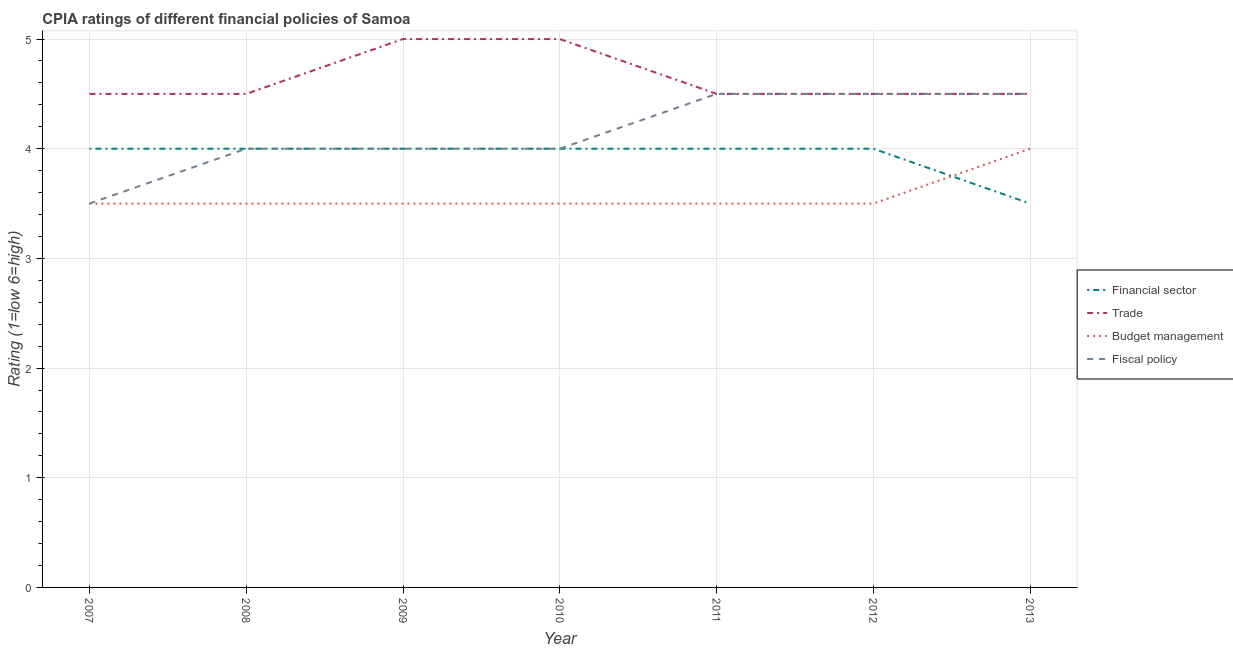How many different coloured lines are there?
Provide a short and direct response. 4. Does the line corresponding to cpia rating of trade intersect with the line corresponding to cpia rating of budget management?
Make the answer very short. No. Is the number of lines equal to the number of legend labels?
Your answer should be very brief. Yes. Across all years, what is the maximum cpia rating of budget management?
Provide a succinct answer. 4. In which year was the cpia rating of fiscal policy maximum?
Your response must be concise. 2011. What is the difference between the cpia rating of fiscal policy in 2009 and that in 2012?
Keep it short and to the point. -0.5. What is the difference between the cpia rating of financial sector in 2012 and the cpia rating of budget management in 2007?
Offer a very short reply. 0.5. What is the average cpia rating of trade per year?
Your answer should be very brief. 4.64. In the year 2011, what is the difference between the cpia rating of budget management and cpia rating of fiscal policy?
Ensure brevity in your answer.  -1. What is the ratio of the cpia rating of budget management in 2010 to that in 2011?
Offer a terse response. 1. Is the cpia rating of trade in 2010 less than that in 2013?
Ensure brevity in your answer.  No. Is the difference between the cpia rating of trade in 2008 and 2013 greater than the difference between the cpia rating of budget management in 2008 and 2013?
Your response must be concise. Yes. What is the difference between the highest and the lowest cpia rating of trade?
Offer a terse response. 0.5. In how many years, is the cpia rating of budget management greater than the average cpia rating of budget management taken over all years?
Your answer should be very brief. 1. Is the sum of the cpia rating of fiscal policy in 2008 and 2011 greater than the maximum cpia rating of trade across all years?
Offer a very short reply. Yes. Is it the case that in every year, the sum of the cpia rating of financial sector and cpia rating of trade is greater than the cpia rating of budget management?
Offer a very short reply. Yes. How many lines are there?
Keep it short and to the point. 4. Are the values on the major ticks of Y-axis written in scientific E-notation?
Your answer should be very brief. No. Does the graph contain any zero values?
Your response must be concise. No. Does the graph contain grids?
Offer a terse response. Yes. How many legend labels are there?
Keep it short and to the point. 4. How are the legend labels stacked?
Make the answer very short. Vertical. What is the title of the graph?
Your answer should be very brief. CPIA ratings of different financial policies of Samoa. Does "Payroll services" appear as one of the legend labels in the graph?
Offer a terse response. No. What is the label or title of the X-axis?
Provide a short and direct response. Year. What is the label or title of the Y-axis?
Ensure brevity in your answer.  Rating (1=low 6=high). What is the Rating (1=low 6=high) of Financial sector in 2007?
Keep it short and to the point. 4. What is the Rating (1=low 6=high) of Trade in 2007?
Your response must be concise. 4.5. What is the Rating (1=low 6=high) in Financial sector in 2008?
Offer a very short reply. 4. What is the Rating (1=low 6=high) in Trade in 2008?
Provide a short and direct response. 4.5. What is the Rating (1=low 6=high) of Budget management in 2008?
Your answer should be compact. 3.5. What is the Rating (1=low 6=high) in Fiscal policy in 2008?
Your response must be concise. 4. What is the Rating (1=low 6=high) in Trade in 2009?
Your answer should be very brief. 5. What is the Rating (1=low 6=high) in Trade in 2010?
Ensure brevity in your answer.  5. What is the Rating (1=low 6=high) of Fiscal policy in 2010?
Provide a succinct answer. 4. What is the Rating (1=low 6=high) in Financial sector in 2012?
Provide a short and direct response. 4. What is the Rating (1=low 6=high) in Fiscal policy in 2012?
Give a very brief answer. 4.5. What is the Rating (1=low 6=high) in Trade in 2013?
Offer a terse response. 4.5. What is the Rating (1=low 6=high) of Budget management in 2013?
Provide a succinct answer. 4. What is the Rating (1=low 6=high) in Fiscal policy in 2013?
Offer a terse response. 4.5. Across all years, what is the maximum Rating (1=low 6=high) in Financial sector?
Provide a short and direct response. 4. Across all years, what is the maximum Rating (1=low 6=high) in Trade?
Your answer should be very brief. 5. Across all years, what is the maximum Rating (1=low 6=high) in Budget management?
Offer a very short reply. 4. Across all years, what is the minimum Rating (1=low 6=high) of Financial sector?
Offer a very short reply. 3.5. Across all years, what is the minimum Rating (1=low 6=high) of Budget management?
Provide a short and direct response. 3.5. What is the total Rating (1=low 6=high) in Financial sector in the graph?
Make the answer very short. 27.5. What is the total Rating (1=low 6=high) in Trade in the graph?
Offer a very short reply. 32.5. What is the total Rating (1=low 6=high) of Budget management in the graph?
Provide a short and direct response. 25. What is the total Rating (1=low 6=high) of Fiscal policy in the graph?
Your response must be concise. 29. What is the difference between the Rating (1=low 6=high) in Trade in 2007 and that in 2008?
Make the answer very short. 0. What is the difference between the Rating (1=low 6=high) in Budget management in 2007 and that in 2008?
Offer a terse response. 0. What is the difference between the Rating (1=low 6=high) of Trade in 2007 and that in 2009?
Give a very brief answer. -0.5. What is the difference between the Rating (1=low 6=high) of Budget management in 2007 and that in 2009?
Your response must be concise. 0. What is the difference between the Rating (1=low 6=high) of Financial sector in 2007 and that in 2010?
Your answer should be very brief. 0. What is the difference between the Rating (1=low 6=high) of Trade in 2007 and that in 2010?
Offer a very short reply. -0.5. What is the difference between the Rating (1=low 6=high) of Budget management in 2007 and that in 2010?
Give a very brief answer. 0. What is the difference between the Rating (1=low 6=high) in Financial sector in 2007 and that in 2011?
Your response must be concise. 0. What is the difference between the Rating (1=low 6=high) of Trade in 2007 and that in 2011?
Your answer should be very brief. 0. What is the difference between the Rating (1=low 6=high) of Financial sector in 2007 and that in 2013?
Your answer should be very brief. 0.5. What is the difference between the Rating (1=low 6=high) of Budget management in 2007 and that in 2013?
Offer a terse response. -0.5. What is the difference between the Rating (1=low 6=high) of Fiscal policy in 2007 and that in 2013?
Your answer should be very brief. -1. What is the difference between the Rating (1=low 6=high) in Financial sector in 2008 and that in 2009?
Keep it short and to the point. 0. What is the difference between the Rating (1=low 6=high) of Trade in 2008 and that in 2009?
Provide a succinct answer. -0.5. What is the difference between the Rating (1=low 6=high) of Budget management in 2008 and that in 2009?
Give a very brief answer. 0. What is the difference between the Rating (1=low 6=high) of Trade in 2008 and that in 2010?
Offer a very short reply. -0.5. What is the difference between the Rating (1=low 6=high) of Financial sector in 2008 and that in 2011?
Make the answer very short. 0. What is the difference between the Rating (1=low 6=high) of Trade in 2008 and that in 2011?
Offer a terse response. 0. What is the difference between the Rating (1=low 6=high) of Budget management in 2008 and that in 2011?
Provide a succinct answer. 0. What is the difference between the Rating (1=low 6=high) of Financial sector in 2008 and that in 2012?
Offer a terse response. 0. What is the difference between the Rating (1=low 6=high) in Trade in 2008 and that in 2012?
Provide a succinct answer. 0. What is the difference between the Rating (1=low 6=high) in Budget management in 2008 and that in 2012?
Provide a succinct answer. 0. What is the difference between the Rating (1=low 6=high) of Fiscal policy in 2008 and that in 2012?
Offer a very short reply. -0.5. What is the difference between the Rating (1=low 6=high) in Trade in 2008 and that in 2013?
Offer a terse response. 0. What is the difference between the Rating (1=low 6=high) of Budget management in 2008 and that in 2013?
Give a very brief answer. -0.5. What is the difference between the Rating (1=low 6=high) of Fiscal policy in 2008 and that in 2013?
Provide a short and direct response. -0.5. What is the difference between the Rating (1=low 6=high) of Financial sector in 2009 and that in 2011?
Provide a succinct answer. 0. What is the difference between the Rating (1=low 6=high) in Trade in 2009 and that in 2011?
Your answer should be compact. 0.5. What is the difference between the Rating (1=low 6=high) in Fiscal policy in 2009 and that in 2011?
Make the answer very short. -0.5. What is the difference between the Rating (1=low 6=high) in Financial sector in 2009 and that in 2012?
Keep it short and to the point. 0. What is the difference between the Rating (1=low 6=high) in Trade in 2009 and that in 2012?
Offer a terse response. 0.5. What is the difference between the Rating (1=low 6=high) of Budget management in 2009 and that in 2012?
Ensure brevity in your answer.  0. What is the difference between the Rating (1=low 6=high) in Fiscal policy in 2009 and that in 2012?
Provide a succinct answer. -0.5. What is the difference between the Rating (1=low 6=high) of Trade in 2009 and that in 2013?
Ensure brevity in your answer.  0.5. What is the difference between the Rating (1=low 6=high) of Budget management in 2009 and that in 2013?
Provide a succinct answer. -0.5. What is the difference between the Rating (1=low 6=high) in Trade in 2010 and that in 2011?
Your answer should be compact. 0.5. What is the difference between the Rating (1=low 6=high) in Budget management in 2010 and that in 2011?
Provide a succinct answer. 0. What is the difference between the Rating (1=low 6=high) in Fiscal policy in 2010 and that in 2012?
Keep it short and to the point. -0.5. What is the difference between the Rating (1=low 6=high) of Trade in 2010 and that in 2013?
Keep it short and to the point. 0.5. What is the difference between the Rating (1=low 6=high) in Budget management in 2010 and that in 2013?
Keep it short and to the point. -0.5. What is the difference between the Rating (1=low 6=high) in Fiscal policy in 2010 and that in 2013?
Provide a short and direct response. -0.5. What is the difference between the Rating (1=low 6=high) of Trade in 2011 and that in 2012?
Give a very brief answer. 0. What is the difference between the Rating (1=low 6=high) in Budget management in 2011 and that in 2012?
Offer a terse response. 0. What is the difference between the Rating (1=low 6=high) of Financial sector in 2011 and that in 2013?
Give a very brief answer. 0.5. What is the difference between the Rating (1=low 6=high) in Financial sector in 2012 and that in 2013?
Your answer should be very brief. 0.5. What is the difference between the Rating (1=low 6=high) of Trade in 2012 and that in 2013?
Provide a succinct answer. 0. What is the difference between the Rating (1=low 6=high) in Budget management in 2012 and that in 2013?
Your response must be concise. -0.5. What is the difference between the Rating (1=low 6=high) of Fiscal policy in 2012 and that in 2013?
Ensure brevity in your answer.  0. What is the difference between the Rating (1=low 6=high) of Financial sector in 2007 and the Rating (1=low 6=high) of Trade in 2008?
Keep it short and to the point. -0.5. What is the difference between the Rating (1=low 6=high) in Financial sector in 2007 and the Rating (1=low 6=high) in Budget management in 2008?
Your answer should be compact. 0.5. What is the difference between the Rating (1=low 6=high) of Financial sector in 2007 and the Rating (1=low 6=high) of Fiscal policy in 2008?
Your answer should be very brief. 0. What is the difference between the Rating (1=low 6=high) of Trade in 2007 and the Rating (1=low 6=high) of Budget management in 2008?
Your answer should be very brief. 1. What is the difference between the Rating (1=low 6=high) in Financial sector in 2007 and the Rating (1=low 6=high) in Budget management in 2009?
Offer a terse response. 0.5. What is the difference between the Rating (1=low 6=high) of Trade in 2007 and the Rating (1=low 6=high) of Budget management in 2009?
Provide a succinct answer. 1. What is the difference between the Rating (1=low 6=high) in Budget management in 2007 and the Rating (1=low 6=high) in Fiscal policy in 2009?
Your answer should be very brief. -0.5. What is the difference between the Rating (1=low 6=high) of Budget management in 2007 and the Rating (1=low 6=high) of Fiscal policy in 2010?
Offer a very short reply. -0.5. What is the difference between the Rating (1=low 6=high) of Trade in 2007 and the Rating (1=low 6=high) of Budget management in 2011?
Your response must be concise. 1. What is the difference between the Rating (1=low 6=high) of Budget management in 2007 and the Rating (1=low 6=high) of Fiscal policy in 2011?
Give a very brief answer. -1. What is the difference between the Rating (1=low 6=high) of Financial sector in 2007 and the Rating (1=low 6=high) of Trade in 2012?
Your response must be concise. -0.5. What is the difference between the Rating (1=low 6=high) in Financial sector in 2007 and the Rating (1=low 6=high) in Budget management in 2012?
Provide a short and direct response. 0.5. What is the difference between the Rating (1=low 6=high) in Financial sector in 2007 and the Rating (1=low 6=high) in Fiscal policy in 2012?
Offer a very short reply. -0.5. What is the difference between the Rating (1=low 6=high) of Trade in 2007 and the Rating (1=low 6=high) of Budget management in 2012?
Ensure brevity in your answer.  1. What is the difference between the Rating (1=low 6=high) in Trade in 2007 and the Rating (1=low 6=high) in Fiscal policy in 2012?
Your answer should be very brief. 0. What is the difference between the Rating (1=low 6=high) of Budget management in 2007 and the Rating (1=low 6=high) of Fiscal policy in 2012?
Your answer should be compact. -1. What is the difference between the Rating (1=low 6=high) in Financial sector in 2007 and the Rating (1=low 6=high) in Fiscal policy in 2013?
Give a very brief answer. -0.5. What is the difference between the Rating (1=low 6=high) of Trade in 2007 and the Rating (1=low 6=high) of Budget management in 2013?
Provide a short and direct response. 0.5. What is the difference between the Rating (1=low 6=high) in Budget management in 2007 and the Rating (1=low 6=high) in Fiscal policy in 2013?
Offer a terse response. -1. What is the difference between the Rating (1=low 6=high) in Financial sector in 2008 and the Rating (1=low 6=high) in Budget management in 2009?
Provide a succinct answer. 0.5. What is the difference between the Rating (1=low 6=high) of Budget management in 2008 and the Rating (1=low 6=high) of Fiscal policy in 2009?
Your answer should be compact. -0.5. What is the difference between the Rating (1=low 6=high) in Financial sector in 2008 and the Rating (1=low 6=high) in Trade in 2010?
Offer a very short reply. -1. What is the difference between the Rating (1=low 6=high) in Financial sector in 2008 and the Rating (1=low 6=high) in Fiscal policy in 2010?
Make the answer very short. 0. What is the difference between the Rating (1=low 6=high) of Budget management in 2008 and the Rating (1=low 6=high) of Fiscal policy in 2010?
Your answer should be very brief. -0.5. What is the difference between the Rating (1=low 6=high) of Financial sector in 2008 and the Rating (1=low 6=high) of Trade in 2011?
Your answer should be compact. -0.5. What is the difference between the Rating (1=low 6=high) in Trade in 2008 and the Rating (1=low 6=high) in Budget management in 2011?
Your answer should be very brief. 1. What is the difference between the Rating (1=low 6=high) of Budget management in 2008 and the Rating (1=low 6=high) of Fiscal policy in 2011?
Give a very brief answer. -1. What is the difference between the Rating (1=low 6=high) in Financial sector in 2008 and the Rating (1=low 6=high) in Fiscal policy in 2012?
Your response must be concise. -0.5. What is the difference between the Rating (1=low 6=high) in Trade in 2008 and the Rating (1=low 6=high) in Fiscal policy in 2012?
Ensure brevity in your answer.  0. What is the difference between the Rating (1=low 6=high) of Budget management in 2008 and the Rating (1=low 6=high) of Fiscal policy in 2012?
Keep it short and to the point. -1. What is the difference between the Rating (1=low 6=high) of Financial sector in 2008 and the Rating (1=low 6=high) of Budget management in 2013?
Ensure brevity in your answer.  0. What is the difference between the Rating (1=low 6=high) in Financial sector in 2009 and the Rating (1=low 6=high) in Budget management in 2010?
Your response must be concise. 0.5. What is the difference between the Rating (1=low 6=high) in Financial sector in 2009 and the Rating (1=low 6=high) in Trade in 2011?
Offer a very short reply. -0.5. What is the difference between the Rating (1=low 6=high) in Financial sector in 2009 and the Rating (1=low 6=high) in Fiscal policy in 2012?
Ensure brevity in your answer.  -0.5. What is the difference between the Rating (1=low 6=high) in Trade in 2009 and the Rating (1=low 6=high) in Budget management in 2012?
Offer a very short reply. 1.5. What is the difference between the Rating (1=low 6=high) of Financial sector in 2009 and the Rating (1=low 6=high) of Trade in 2013?
Provide a succinct answer. -0.5. What is the difference between the Rating (1=low 6=high) of Financial sector in 2009 and the Rating (1=low 6=high) of Fiscal policy in 2013?
Provide a short and direct response. -0.5. What is the difference between the Rating (1=low 6=high) of Trade in 2009 and the Rating (1=low 6=high) of Budget management in 2013?
Your answer should be compact. 1. What is the difference between the Rating (1=low 6=high) of Budget management in 2009 and the Rating (1=low 6=high) of Fiscal policy in 2013?
Offer a terse response. -1. What is the difference between the Rating (1=low 6=high) of Financial sector in 2010 and the Rating (1=low 6=high) of Trade in 2011?
Make the answer very short. -0.5. What is the difference between the Rating (1=low 6=high) in Financial sector in 2010 and the Rating (1=low 6=high) in Budget management in 2011?
Give a very brief answer. 0.5. What is the difference between the Rating (1=low 6=high) of Financial sector in 2010 and the Rating (1=low 6=high) of Fiscal policy in 2011?
Offer a terse response. -0.5. What is the difference between the Rating (1=low 6=high) in Trade in 2010 and the Rating (1=low 6=high) in Budget management in 2011?
Keep it short and to the point. 1.5. What is the difference between the Rating (1=low 6=high) in Trade in 2010 and the Rating (1=low 6=high) in Fiscal policy in 2011?
Your answer should be compact. 0.5. What is the difference between the Rating (1=low 6=high) in Financial sector in 2010 and the Rating (1=low 6=high) in Trade in 2012?
Your response must be concise. -0.5. What is the difference between the Rating (1=low 6=high) in Financial sector in 2010 and the Rating (1=low 6=high) in Budget management in 2012?
Provide a succinct answer. 0.5. What is the difference between the Rating (1=low 6=high) of Financial sector in 2010 and the Rating (1=low 6=high) of Fiscal policy in 2012?
Your answer should be compact. -0.5. What is the difference between the Rating (1=low 6=high) of Budget management in 2010 and the Rating (1=low 6=high) of Fiscal policy in 2012?
Give a very brief answer. -1. What is the difference between the Rating (1=low 6=high) in Financial sector in 2010 and the Rating (1=low 6=high) in Trade in 2013?
Offer a very short reply. -0.5. What is the difference between the Rating (1=low 6=high) in Trade in 2010 and the Rating (1=low 6=high) in Budget management in 2013?
Keep it short and to the point. 1. What is the difference between the Rating (1=low 6=high) in Budget management in 2010 and the Rating (1=low 6=high) in Fiscal policy in 2013?
Provide a succinct answer. -1. What is the difference between the Rating (1=low 6=high) of Financial sector in 2011 and the Rating (1=low 6=high) of Budget management in 2012?
Offer a very short reply. 0.5. What is the difference between the Rating (1=low 6=high) in Trade in 2011 and the Rating (1=low 6=high) in Budget management in 2012?
Your response must be concise. 1. What is the difference between the Rating (1=low 6=high) of Trade in 2011 and the Rating (1=low 6=high) of Fiscal policy in 2012?
Your response must be concise. 0. What is the difference between the Rating (1=low 6=high) of Financial sector in 2011 and the Rating (1=low 6=high) of Budget management in 2013?
Provide a succinct answer. 0. What is the difference between the Rating (1=low 6=high) of Trade in 2011 and the Rating (1=low 6=high) of Fiscal policy in 2013?
Your answer should be compact. 0. What is the difference between the Rating (1=low 6=high) in Budget management in 2011 and the Rating (1=low 6=high) in Fiscal policy in 2013?
Your answer should be very brief. -1. What is the difference between the Rating (1=low 6=high) of Financial sector in 2012 and the Rating (1=low 6=high) of Trade in 2013?
Offer a very short reply. -0.5. What is the difference between the Rating (1=low 6=high) of Financial sector in 2012 and the Rating (1=low 6=high) of Budget management in 2013?
Keep it short and to the point. 0. What is the difference between the Rating (1=low 6=high) of Financial sector in 2012 and the Rating (1=low 6=high) of Fiscal policy in 2013?
Offer a very short reply. -0.5. What is the difference between the Rating (1=low 6=high) of Trade in 2012 and the Rating (1=low 6=high) of Fiscal policy in 2013?
Make the answer very short. 0. What is the average Rating (1=low 6=high) in Financial sector per year?
Offer a very short reply. 3.93. What is the average Rating (1=low 6=high) in Trade per year?
Your response must be concise. 4.64. What is the average Rating (1=low 6=high) of Budget management per year?
Provide a succinct answer. 3.57. What is the average Rating (1=low 6=high) of Fiscal policy per year?
Make the answer very short. 4.14. In the year 2007, what is the difference between the Rating (1=low 6=high) in Financial sector and Rating (1=low 6=high) in Budget management?
Provide a succinct answer. 0.5. In the year 2007, what is the difference between the Rating (1=low 6=high) of Budget management and Rating (1=low 6=high) of Fiscal policy?
Your answer should be very brief. 0. In the year 2008, what is the difference between the Rating (1=low 6=high) of Financial sector and Rating (1=low 6=high) of Trade?
Offer a very short reply. -0.5. In the year 2008, what is the difference between the Rating (1=low 6=high) of Financial sector and Rating (1=low 6=high) of Budget management?
Your response must be concise. 0.5. In the year 2008, what is the difference between the Rating (1=low 6=high) in Financial sector and Rating (1=low 6=high) in Fiscal policy?
Offer a terse response. 0. In the year 2008, what is the difference between the Rating (1=low 6=high) of Budget management and Rating (1=low 6=high) of Fiscal policy?
Provide a succinct answer. -0.5. In the year 2009, what is the difference between the Rating (1=low 6=high) in Trade and Rating (1=low 6=high) in Fiscal policy?
Offer a very short reply. 1. In the year 2010, what is the difference between the Rating (1=low 6=high) of Financial sector and Rating (1=low 6=high) of Trade?
Give a very brief answer. -1. In the year 2010, what is the difference between the Rating (1=low 6=high) in Financial sector and Rating (1=low 6=high) in Budget management?
Your response must be concise. 0.5. In the year 2010, what is the difference between the Rating (1=low 6=high) of Financial sector and Rating (1=low 6=high) of Fiscal policy?
Your answer should be compact. 0. In the year 2010, what is the difference between the Rating (1=low 6=high) of Trade and Rating (1=low 6=high) of Budget management?
Make the answer very short. 1.5. In the year 2010, what is the difference between the Rating (1=low 6=high) in Trade and Rating (1=low 6=high) in Fiscal policy?
Keep it short and to the point. 1. In the year 2010, what is the difference between the Rating (1=low 6=high) of Budget management and Rating (1=low 6=high) of Fiscal policy?
Provide a succinct answer. -0.5. In the year 2011, what is the difference between the Rating (1=low 6=high) in Financial sector and Rating (1=low 6=high) in Budget management?
Your response must be concise. 0.5. In the year 2011, what is the difference between the Rating (1=low 6=high) in Budget management and Rating (1=low 6=high) in Fiscal policy?
Give a very brief answer. -1. In the year 2012, what is the difference between the Rating (1=low 6=high) in Trade and Rating (1=low 6=high) in Budget management?
Your answer should be very brief. 1. In the year 2012, what is the difference between the Rating (1=low 6=high) in Trade and Rating (1=low 6=high) in Fiscal policy?
Your answer should be very brief. 0. In the year 2013, what is the difference between the Rating (1=low 6=high) of Financial sector and Rating (1=low 6=high) of Budget management?
Provide a succinct answer. -0.5. In the year 2013, what is the difference between the Rating (1=low 6=high) in Trade and Rating (1=low 6=high) in Budget management?
Keep it short and to the point. 0.5. In the year 2013, what is the difference between the Rating (1=low 6=high) in Trade and Rating (1=low 6=high) in Fiscal policy?
Offer a very short reply. 0. In the year 2013, what is the difference between the Rating (1=low 6=high) in Budget management and Rating (1=low 6=high) in Fiscal policy?
Offer a very short reply. -0.5. What is the ratio of the Rating (1=low 6=high) of Budget management in 2007 to that in 2008?
Your answer should be very brief. 1. What is the ratio of the Rating (1=low 6=high) in Financial sector in 2007 to that in 2009?
Provide a succinct answer. 1. What is the ratio of the Rating (1=low 6=high) of Budget management in 2007 to that in 2009?
Your answer should be very brief. 1. What is the ratio of the Rating (1=low 6=high) in Fiscal policy in 2007 to that in 2009?
Offer a very short reply. 0.88. What is the ratio of the Rating (1=low 6=high) of Trade in 2007 to that in 2010?
Give a very brief answer. 0.9. What is the ratio of the Rating (1=low 6=high) of Budget management in 2007 to that in 2010?
Your answer should be very brief. 1. What is the ratio of the Rating (1=low 6=high) of Trade in 2007 to that in 2011?
Ensure brevity in your answer.  1. What is the ratio of the Rating (1=low 6=high) of Budget management in 2007 to that in 2011?
Give a very brief answer. 1. What is the ratio of the Rating (1=low 6=high) of Financial sector in 2007 to that in 2012?
Your answer should be very brief. 1. What is the ratio of the Rating (1=low 6=high) of Fiscal policy in 2007 to that in 2012?
Provide a short and direct response. 0.78. What is the ratio of the Rating (1=low 6=high) in Budget management in 2007 to that in 2013?
Keep it short and to the point. 0.88. What is the ratio of the Rating (1=low 6=high) of Financial sector in 2008 to that in 2009?
Your response must be concise. 1. What is the ratio of the Rating (1=low 6=high) in Budget management in 2008 to that in 2009?
Give a very brief answer. 1. What is the ratio of the Rating (1=low 6=high) of Financial sector in 2008 to that in 2011?
Offer a terse response. 1. What is the ratio of the Rating (1=low 6=high) in Trade in 2008 to that in 2011?
Give a very brief answer. 1. What is the ratio of the Rating (1=low 6=high) in Budget management in 2008 to that in 2011?
Your answer should be compact. 1. What is the ratio of the Rating (1=low 6=high) of Trade in 2008 to that in 2012?
Your answer should be very brief. 1. What is the ratio of the Rating (1=low 6=high) in Financial sector in 2008 to that in 2013?
Provide a short and direct response. 1.14. What is the ratio of the Rating (1=low 6=high) in Budget management in 2008 to that in 2013?
Provide a short and direct response. 0.88. What is the ratio of the Rating (1=low 6=high) in Fiscal policy in 2008 to that in 2013?
Provide a succinct answer. 0.89. What is the ratio of the Rating (1=low 6=high) in Budget management in 2009 to that in 2010?
Your response must be concise. 1. What is the ratio of the Rating (1=low 6=high) of Financial sector in 2009 to that in 2011?
Ensure brevity in your answer.  1. What is the ratio of the Rating (1=low 6=high) in Trade in 2009 to that in 2011?
Your response must be concise. 1.11. What is the ratio of the Rating (1=low 6=high) of Budget management in 2009 to that in 2011?
Give a very brief answer. 1. What is the ratio of the Rating (1=low 6=high) in Financial sector in 2009 to that in 2012?
Your answer should be compact. 1. What is the ratio of the Rating (1=low 6=high) in Trade in 2009 to that in 2012?
Your response must be concise. 1.11. What is the ratio of the Rating (1=low 6=high) of Fiscal policy in 2009 to that in 2012?
Your answer should be compact. 0.89. What is the ratio of the Rating (1=low 6=high) in Financial sector in 2009 to that in 2013?
Make the answer very short. 1.14. What is the ratio of the Rating (1=low 6=high) of Budget management in 2009 to that in 2013?
Your answer should be very brief. 0.88. What is the ratio of the Rating (1=low 6=high) in Fiscal policy in 2009 to that in 2013?
Give a very brief answer. 0.89. What is the ratio of the Rating (1=low 6=high) in Financial sector in 2010 to that in 2011?
Ensure brevity in your answer.  1. What is the ratio of the Rating (1=low 6=high) of Fiscal policy in 2010 to that in 2011?
Give a very brief answer. 0.89. What is the ratio of the Rating (1=low 6=high) in Financial sector in 2010 to that in 2012?
Give a very brief answer. 1. What is the ratio of the Rating (1=low 6=high) in Trade in 2010 to that in 2012?
Your answer should be very brief. 1.11. What is the ratio of the Rating (1=low 6=high) in Fiscal policy in 2010 to that in 2012?
Ensure brevity in your answer.  0.89. What is the ratio of the Rating (1=low 6=high) in Financial sector in 2010 to that in 2013?
Your answer should be compact. 1.14. What is the ratio of the Rating (1=low 6=high) in Financial sector in 2011 to that in 2013?
Your response must be concise. 1.14. What is the ratio of the Rating (1=low 6=high) in Budget management in 2011 to that in 2013?
Offer a terse response. 0.88. What is the ratio of the Rating (1=low 6=high) of Financial sector in 2012 to that in 2013?
Provide a short and direct response. 1.14. What is the ratio of the Rating (1=low 6=high) in Budget management in 2012 to that in 2013?
Offer a very short reply. 0.88. What is the ratio of the Rating (1=low 6=high) of Fiscal policy in 2012 to that in 2013?
Give a very brief answer. 1. What is the difference between the highest and the second highest Rating (1=low 6=high) of Fiscal policy?
Keep it short and to the point. 0. What is the difference between the highest and the lowest Rating (1=low 6=high) of Fiscal policy?
Provide a succinct answer. 1. 